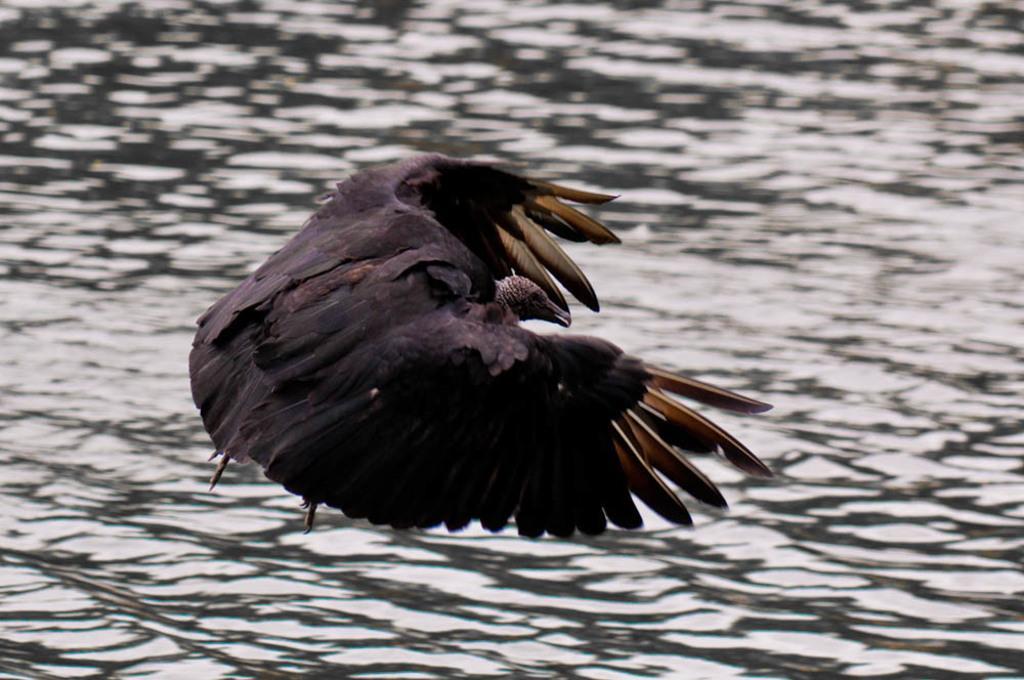In one or two sentences, can you explain what this image depicts? In this image, we can see a bird. We can also see some water. 